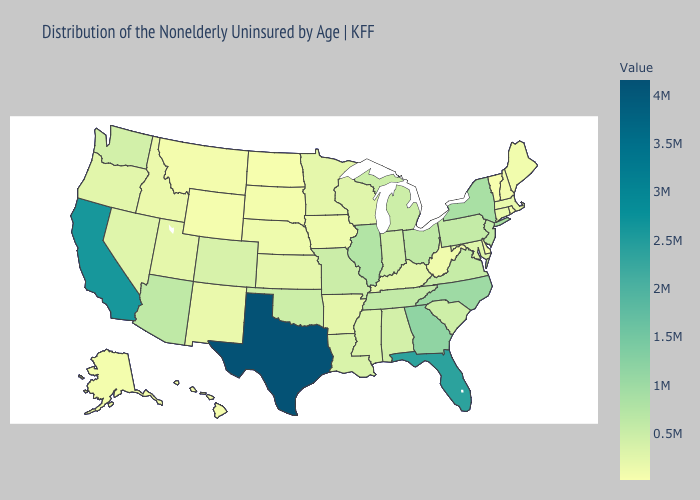Which states have the highest value in the USA?
Short answer required. Texas. Does Texas have the highest value in the USA?
Quick response, please. Yes. Does New Mexico have the lowest value in the West?
Concise answer only. No. Does Vermont have the lowest value in the USA?
Give a very brief answer. Yes. Does Vermont have the lowest value in the USA?
Be succinct. Yes. Among the states that border North Carolina , which have the lowest value?
Short answer required. South Carolina. Among the states that border Nebraska , which have the highest value?
Keep it brief. Missouri. 